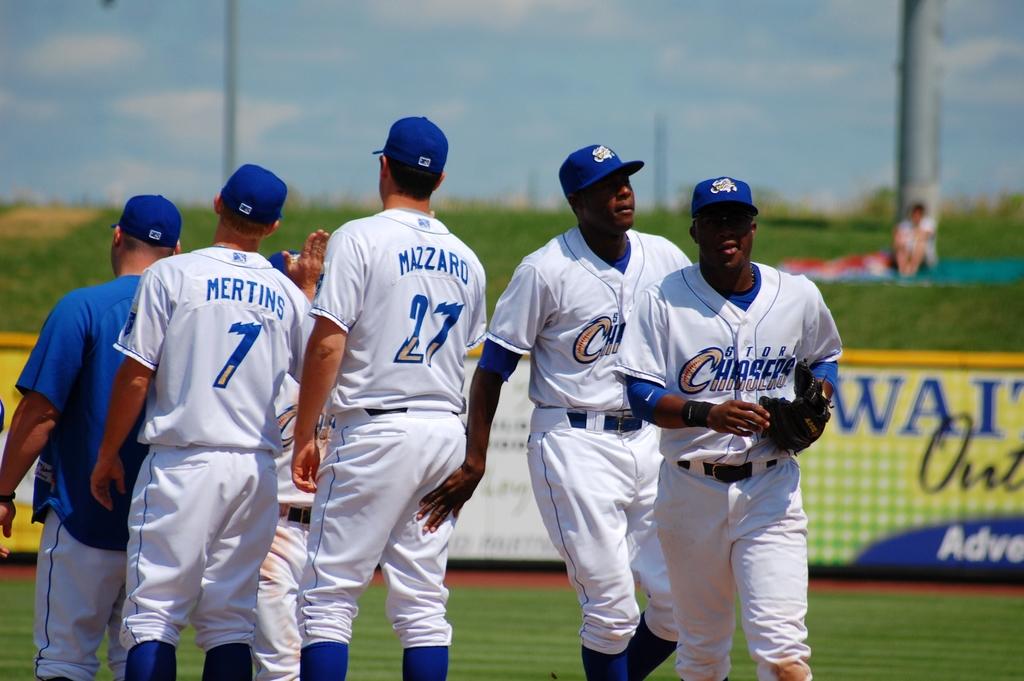What team do the players play for?
Make the answer very short. Storm chasers. What number is the player mertins?
Make the answer very short. 7. 